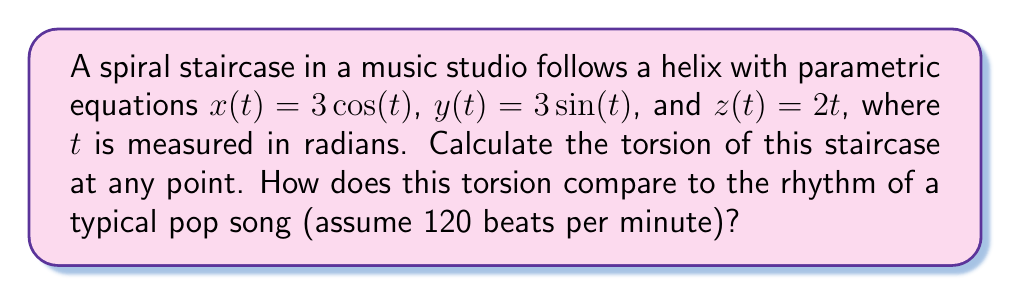What is the answer to this math problem? To compute the torsion of the spiral staircase, we'll follow these steps:

1) First, we need to calculate the first, second, and third derivatives of the position vector $\mathbf{r}(t) = (3\cos(t), 3\sin(t), 2t)$.

   $\mathbf{r}'(t) = (-3\sin(t), 3\cos(t), 2)$
   $\mathbf{r}''(t) = (-3\cos(t), -3\sin(t), 0)$
   $\mathbf{r}'''(t) = (3\sin(t), -3\cos(t), 0)$

2) The torsion $\tau$ is given by the formula:

   $$\tau = \frac{(\mathbf{r}' \times \mathbf{r}'') \cdot \mathbf{r}'''}{|\mathbf{r}' \times \mathbf{r}''|^2}$$

3) Let's calculate $\mathbf{r}' \times \mathbf{r}''$:

   $\mathbf{r}' \times \mathbf{r}'' = (6, 6, 9\sin^2(t) + 9\cos^2(t)) = (6, 6, 9)$

4) Now, $(\mathbf{r}' \times \mathbf{r}'') \cdot \mathbf{r}'''$:

   $(6, 6, 9) \cdot (3\sin(t), -3\cos(t), 0) = 18\sin(t) - 18\cos(t) = 0$

5) The magnitude of $\mathbf{r}' \times \mathbf{r}''$:

   $|\mathbf{r}' \times \mathbf{r}''| = \sqrt{6^2 + 6^2 + 9^2} = \sqrt{153}$

6) Substituting into the torsion formula:

   $$\tau = \frac{0}{(\sqrt{153})^2} = 0$$

7) The torsion is constant and equal to zero at all points on the staircase.

8) A typical pop song at 120 beats per minute has a frequency of 2 Hz. The torsion of the staircase (0) does not change with time, while the rhythm of the song repeats 2 times per second.
Answer: $\tau = 0$ 